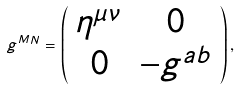<formula> <loc_0><loc_0><loc_500><loc_500>g ^ { M N } = \left ( \begin{array} { c c } \eta ^ { \mu \nu } & 0 \\ 0 & - g ^ { a b } \end{array} \right ) ,</formula> 